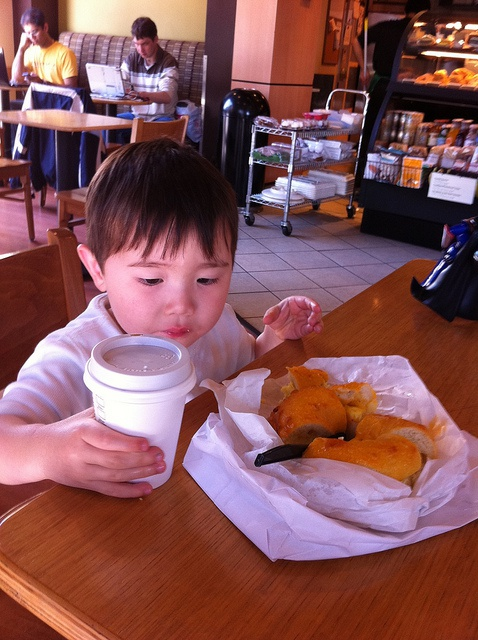Describe the objects in this image and their specific colors. I can see dining table in salmon, maroon, brown, and violet tones, people in salmon, brown, black, lightpink, and pink tones, cup in salmon, lavender, violet, and gray tones, chair in salmon, maroon, brown, and lavender tones, and sandwich in salmon, brown, and maroon tones in this image. 